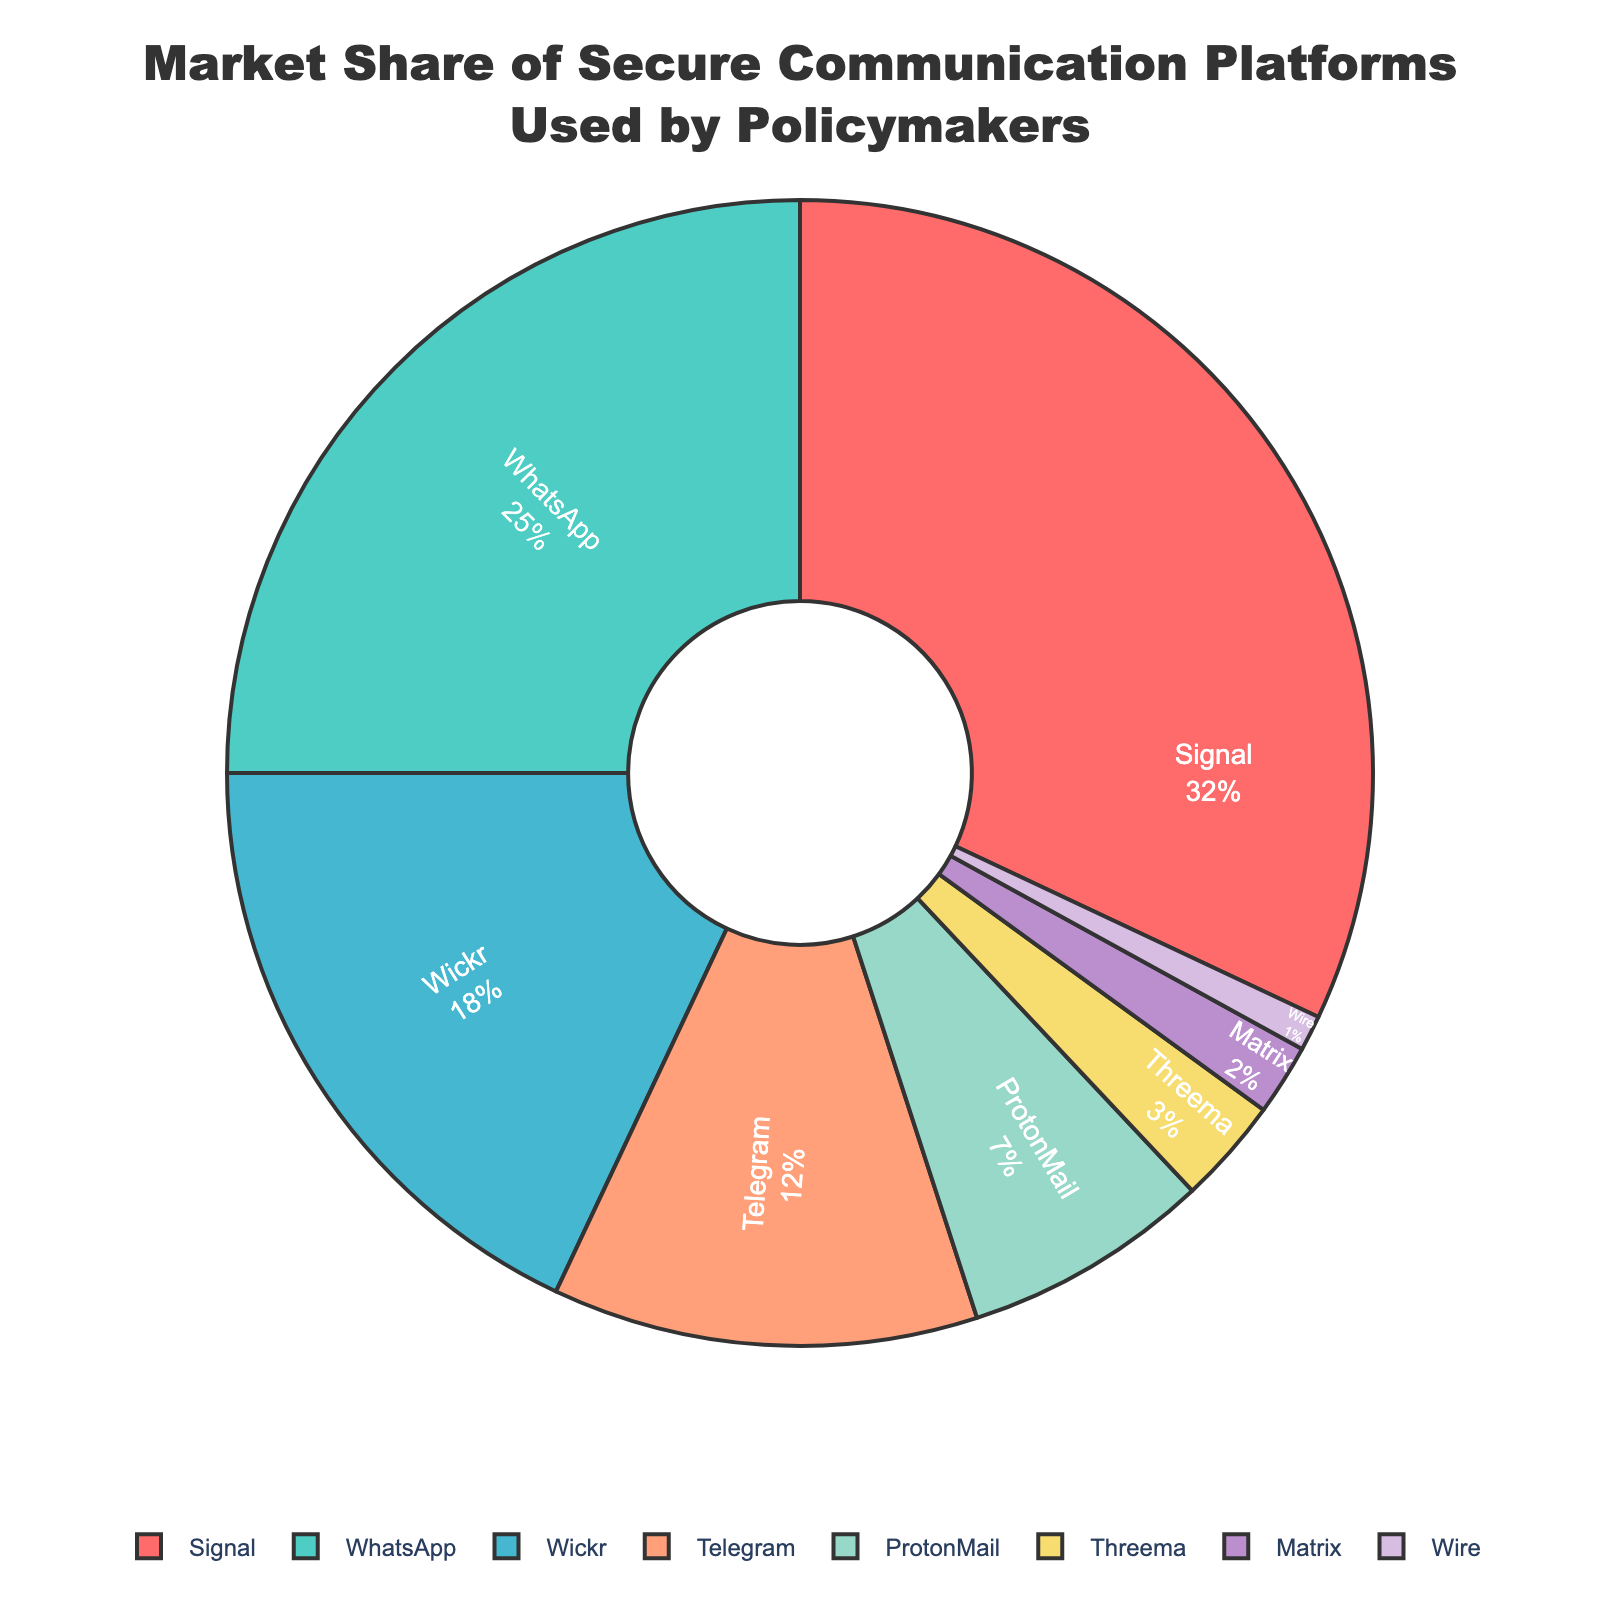What is the platform with the largest market share? Signal has the largest market share as evidenced by it occupying the largest portion of the pie chart. Signal's market share is 32%.
Answer: Signal Which platform has a smaller market share: Telegram or Wickr? Wickr has a larger market share than Telegram. By looking at the pie chart, Wickr's portion is larger than Telegram's. Wickr has 18%, while Telegram has 12%.
Answer: Telegram What’s the combined market share of Signal and WhatsApp? To find the combined market share of Signal and WhatsApp, you add their respective percentages from the pie chart. Signal has 32% and WhatsApp has 25%. Therefore, 32 + 25 = 57%.
Answer: 57% How much more market share does Signal have compared to ProtonMail? Signal’s market share is 32%, and ProtonMail’s market share is 7%. The difference is calculated as 32 - 7 = 25%.
Answer: 25% Which platform has the smallest market share and what is it? Wire has the smallest market share as evidenced by it occupying the smallest portion of the pie chart. Wire’s market share is 1%.
Answer: Wire How much greater is WhatsApp's market share compared to Threema's? WhatsApp's market share is 25%, and Threema's market share is 3%. The difference is calculated as 25 - 3 = 22%.
Answer: 22% If you combine the market shares of Matrix and Wire, do they exceed the market share of ProtonMail? Matrix has a market share of 2% and Wire has 1%, combining them gives 2 + 1 = 3%. ProtonMail has a market share of 7%. Since 3% is less than 7%, they do not exceed ProtonMail’s market share.
Answer: No Which platform occupies the purple section of the pie chart? The pie chart shows Matrix occupying the purple section. By matching the color to the corresponding part of the legend, it is clear that Matrix is purple.
Answer: Matrix Between Wickr and ProtonMail, which has the broader section on the pie chart? Wickr has a broader section on the pie chart than ProtonMail. Wickr's slice is visibly larger with 18% compared to ProtonMail's 7%.
Answer: Wickr 